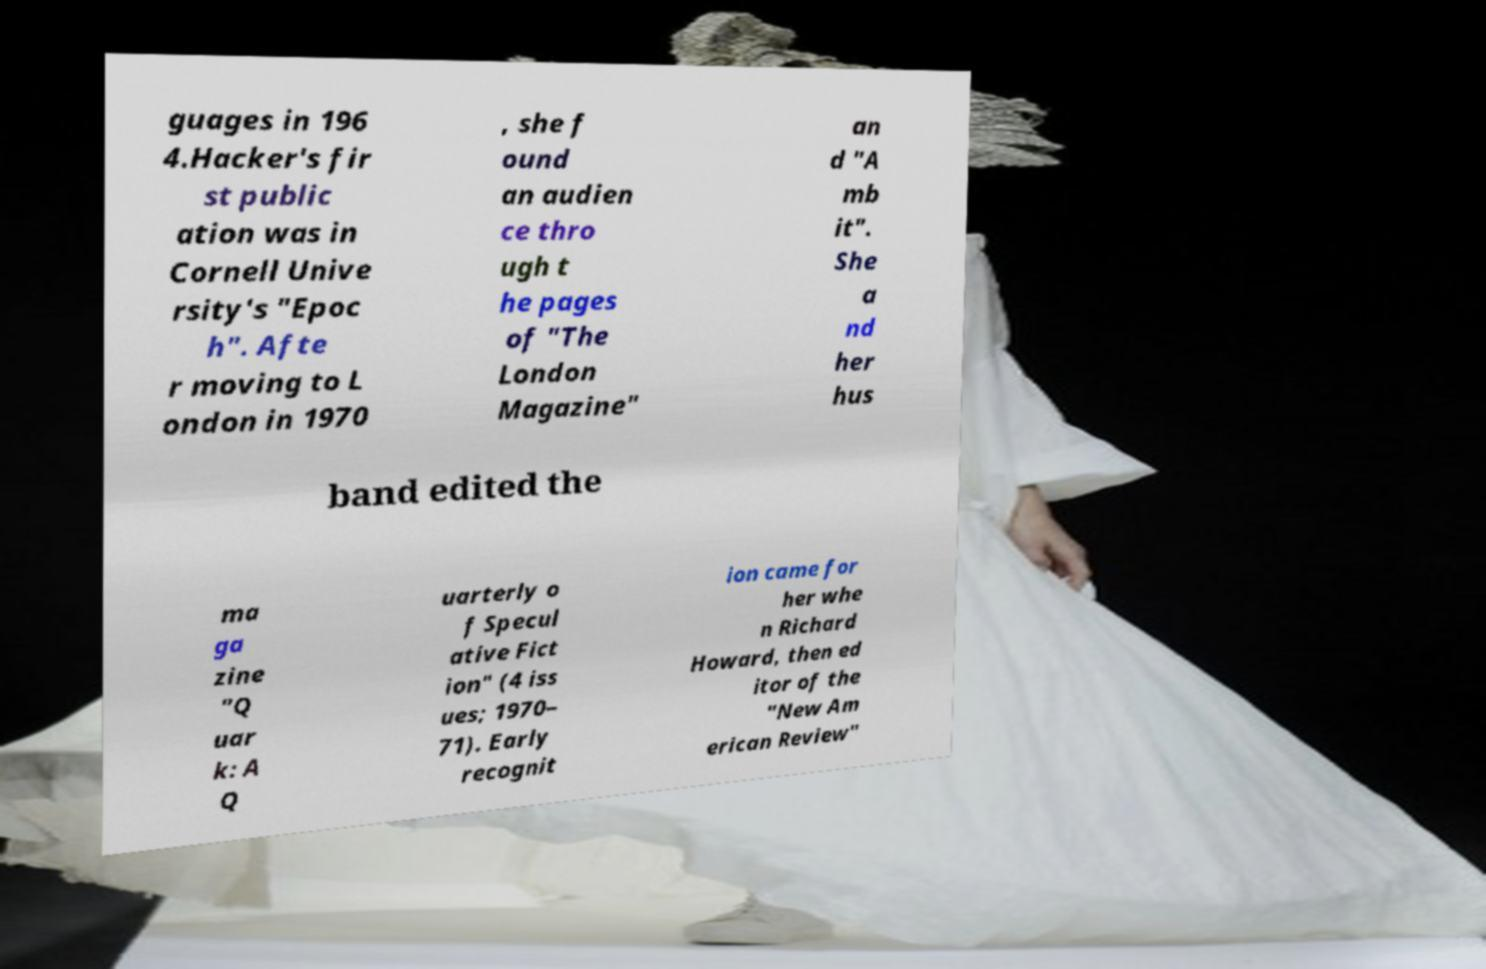Please read and relay the text visible in this image. What does it say? guages in 196 4.Hacker's fir st public ation was in Cornell Unive rsity's "Epoc h". Afte r moving to L ondon in 1970 , she f ound an audien ce thro ugh t he pages of "The London Magazine" an d "A mb it". She a nd her hus band edited the ma ga zine "Q uar k: A Q uarterly o f Specul ative Fict ion" (4 iss ues; 1970– 71). Early recognit ion came for her whe n Richard Howard, then ed itor of the "New Am erican Review" 